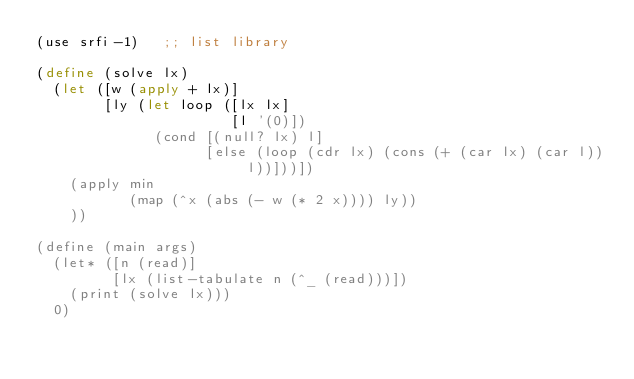Convert code to text. <code><loc_0><loc_0><loc_500><loc_500><_Scheme_>(use srfi-1)   ;; list library

(define (solve lx)
  (let ([w (apply + lx)]
        [ly (let loop ([lx lx]
                       [l '(0)])
              (cond [(null? lx) l]
                    [else (loop (cdr lx) (cons (+ (car lx) (car l)) l))]))])
    (apply min
           (map (^x (abs (- w (* 2 x)))) ly))
    ))

(define (main args)
  (let* ([n (read)]
         [lx (list-tabulate n (^_ (read)))])
    (print (solve lx)))
  0)
</code> 